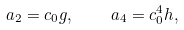Convert formula to latex. <formula><loc_0><loc_0><loc_500><loc_500>a _ { 2 } = c _ { 0 } g , \quad a _ { 4 } = c _ { 0 } ^ { 4 } h ,</formula> 